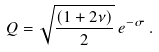<formula> <loc_0><loc_0><loc_500><loc_500>Q = \sqrt { \frac { ( 1 + 2 \nu ) } { 2 } } \, e ^ { - \sigma } \, .</formula> 